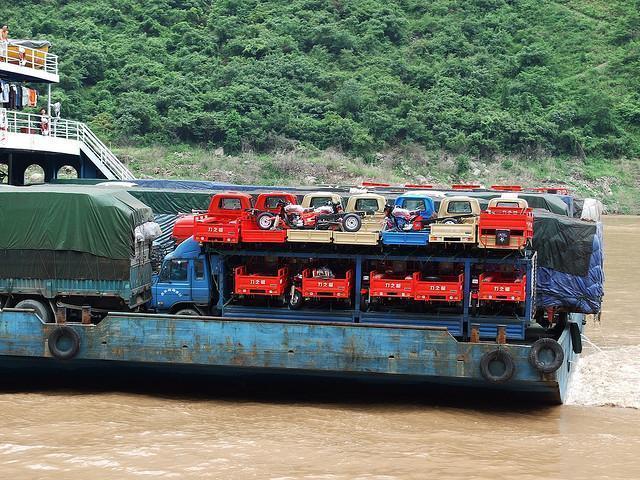Why are all the trucks in back of the boat?
Select the correct answer and articulate reasoning with the following format: 'Answer: answer
Rationale: rationale.'
Options: Stole them, hauling them, part boat, hiding them. Answer: hauling them.
Rationale: The trucks are stacked in such a way that it looks like they are being transported in a way that the trucks could not move themselves. they are all of a similar make and design which implies they are likely being brought for a common and intentional purpose to a new location. 